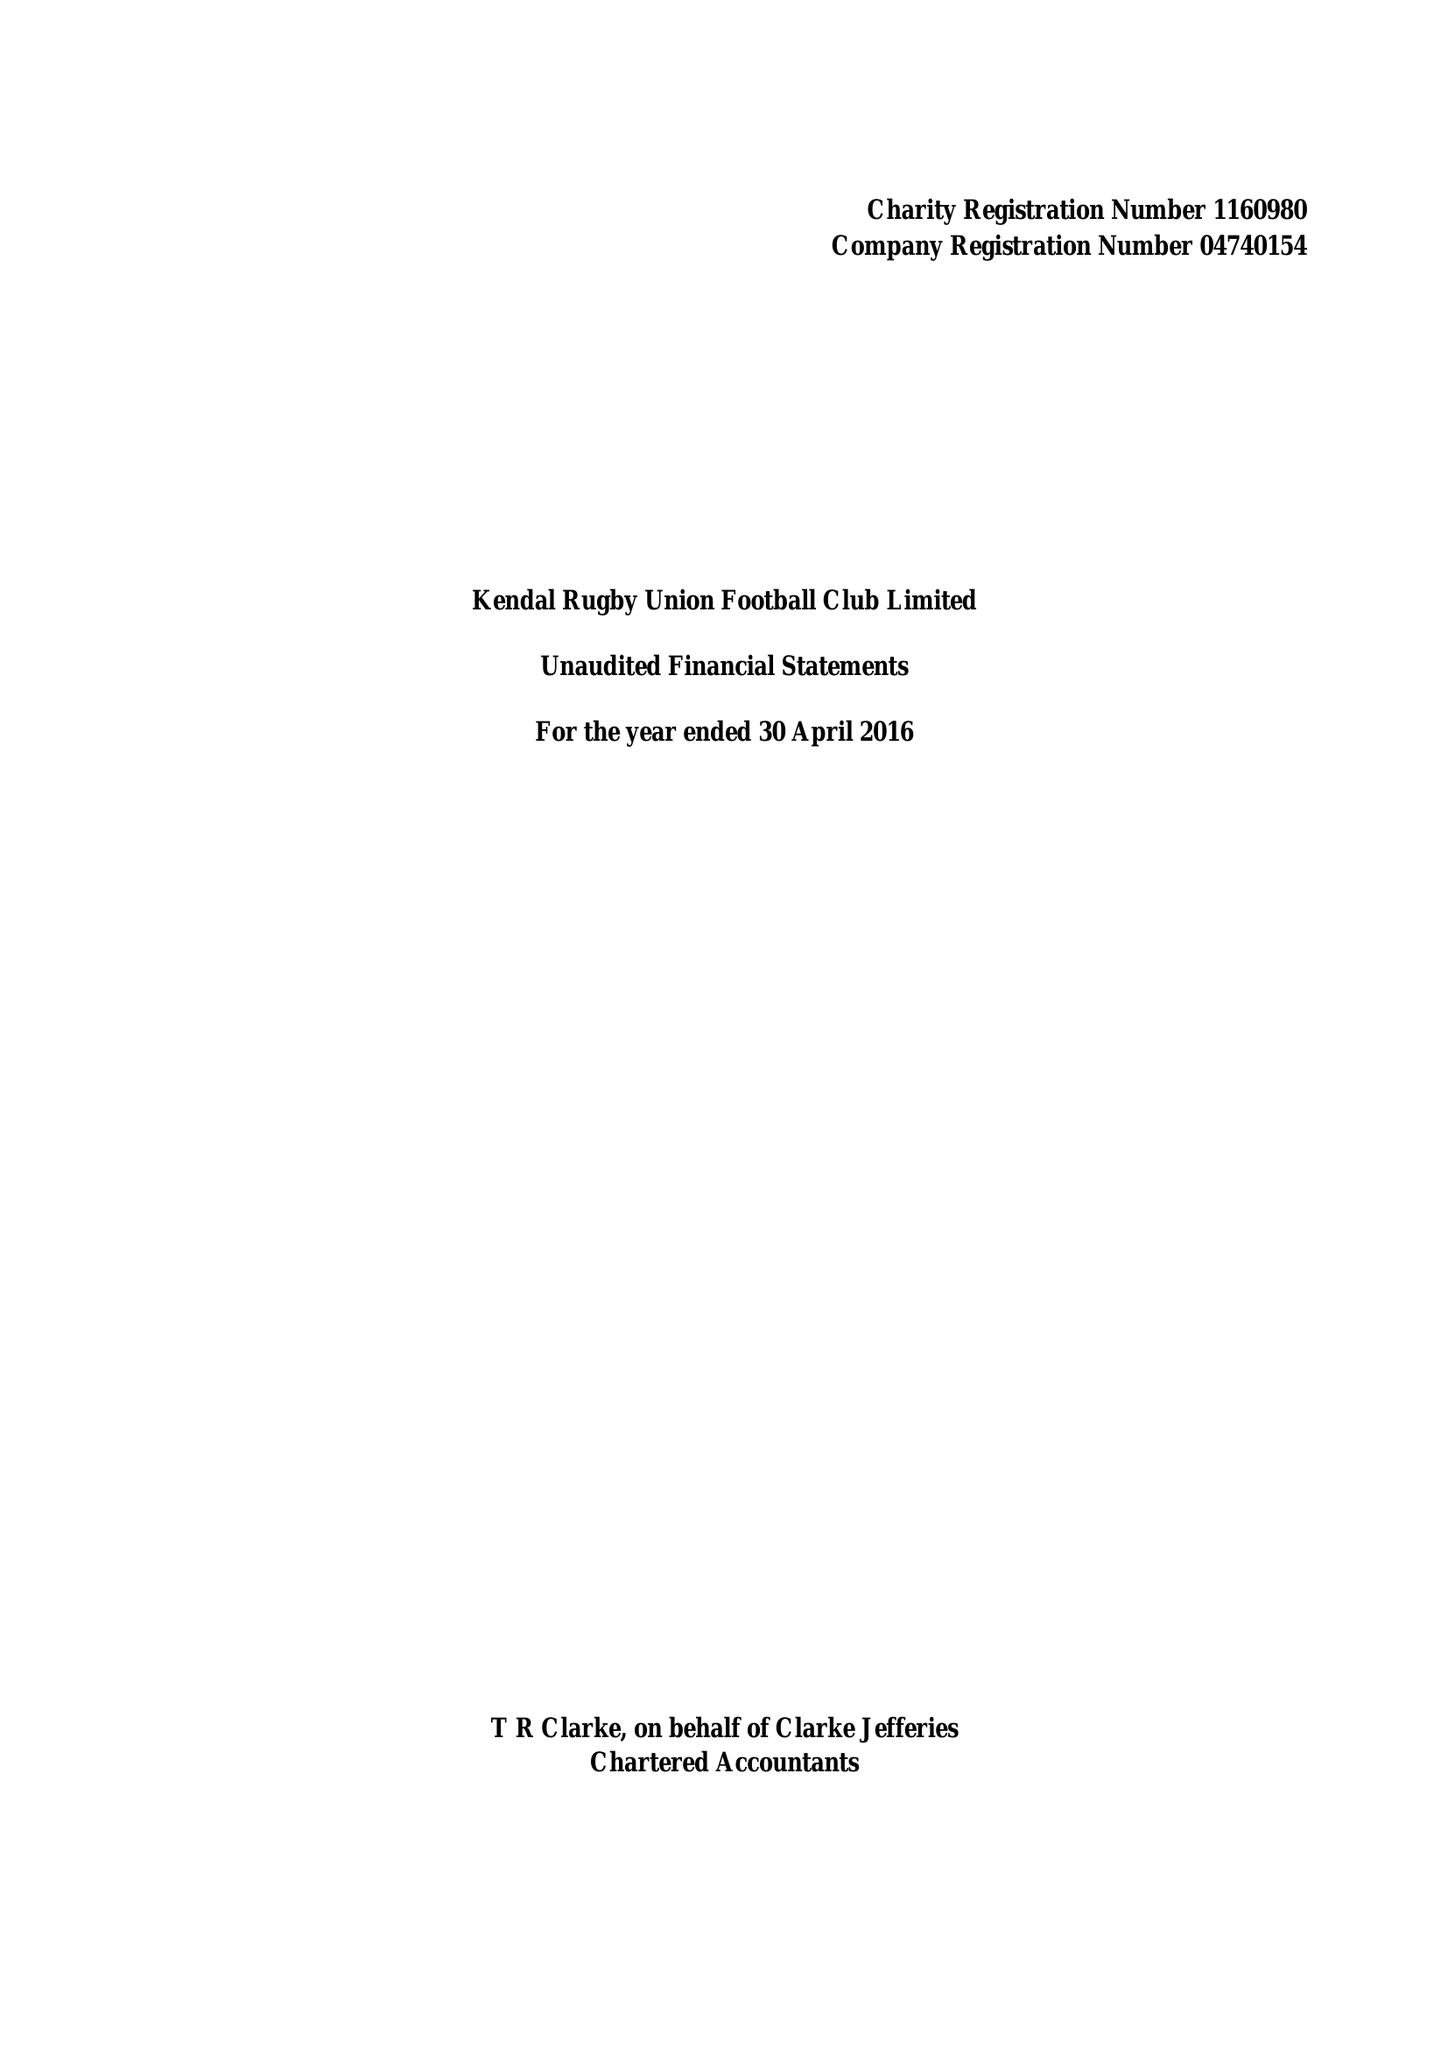What is the value for the income_annually_in_british_pounds?
Answer the question using a single word or phrase. 109512.00 